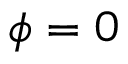Convert formula to latex. <formula><loc_0><loc_0><loc_500><loc_500>\phi = 0</formula> 